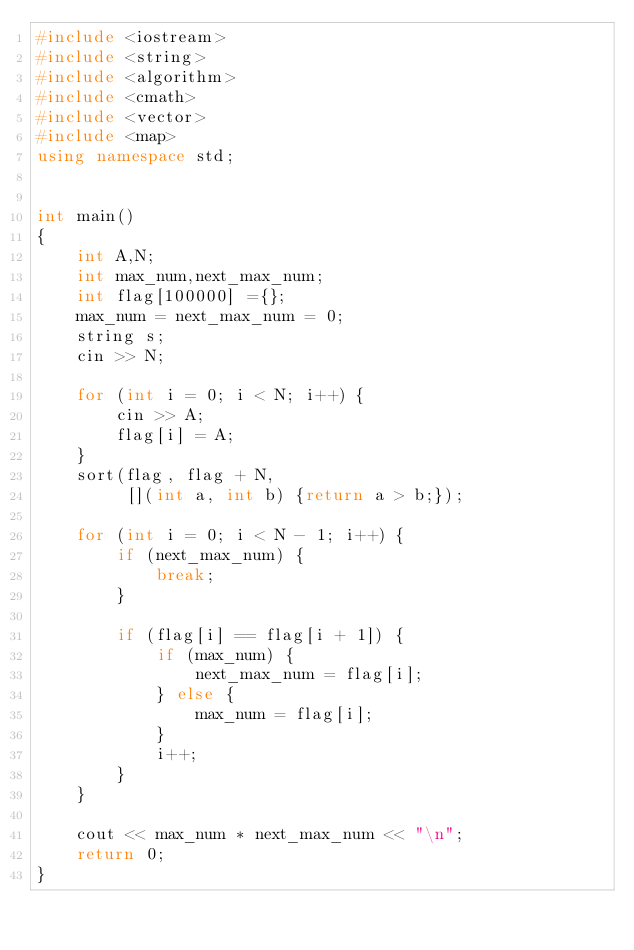Convert code to text. <code><loc_0><loc_0><loc_500><loc_500><_C++_>#include <iostream>
#include <string>
#include <algorithm>
#include <cmath>
#include <vector>
#include <map>
using namespace std;


int main()
{
    int A,N;
    int max_num,next_max_num;
    int flag[100000] ={};
    max_num = next_max_num = 0;
    string s;
    cin >> N;

    for (int i = 0; i < N; i++) {
        cin >> A;
        flag[i] = A;
    }
    sort(flag, flag + N,
         [](int a, int b) {return a > b;});

    for (int i = 0; i < N - 1; i++) {
        if (next_max_num) {
            break;
        }

        if (flag[i] == flag[i + 1]) {
            if (max_num) {
                next_max_num = flag[i];
            } else {
                max_num = flag[i];
            }
            i++;
        }
    }
    
    cout << max_num * next_max_num << "\n";
    return 0;
}</code> 